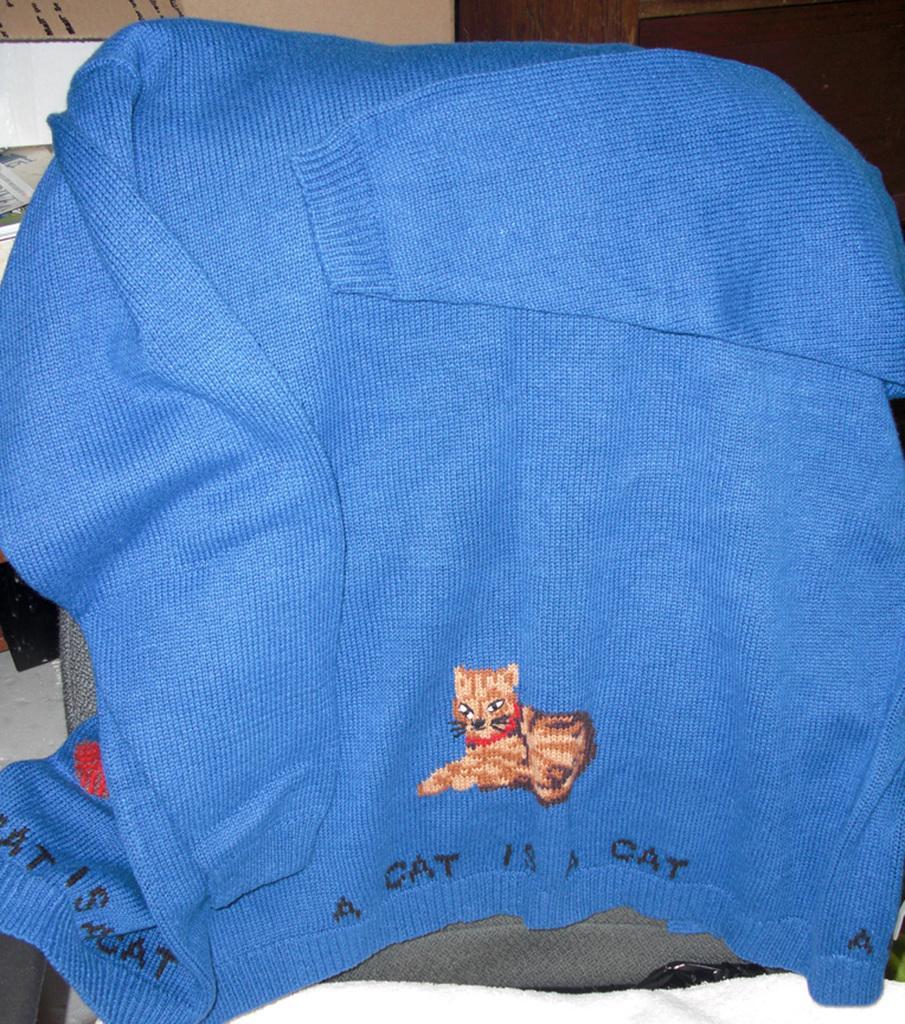Please provide a concise description of this image. In the image there is a blue sweat shirt on clothes and in the back it seems to be a table and a cupboard. 